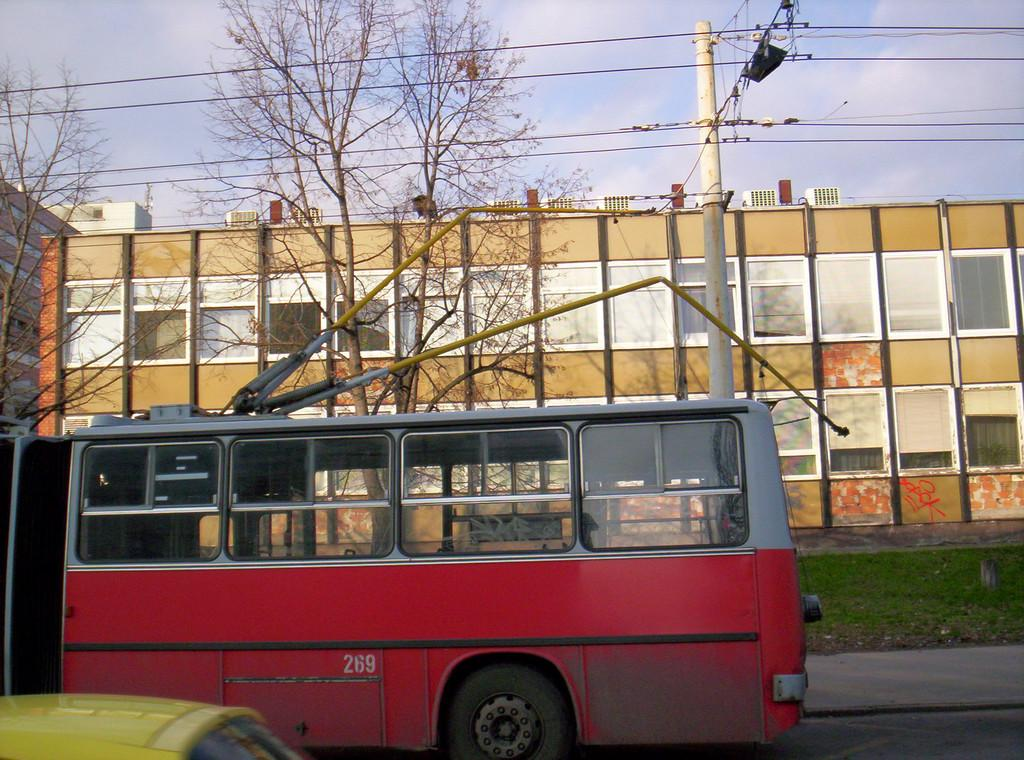What is the main feature of the image? There is a road in the image. What vehicles can be seen on the road? A bus and a car are moving on the road. What can be seen in the background of the image? There is an electric pole, trees, and buildings in the background. What is the condition of the sky in the image? The sky is cloudy in the image. Can you tell me when the robin gave birth in the image? There is no robin or any indication of birth in the image. How many cars are present in the image? There is only one car visible in the image. 